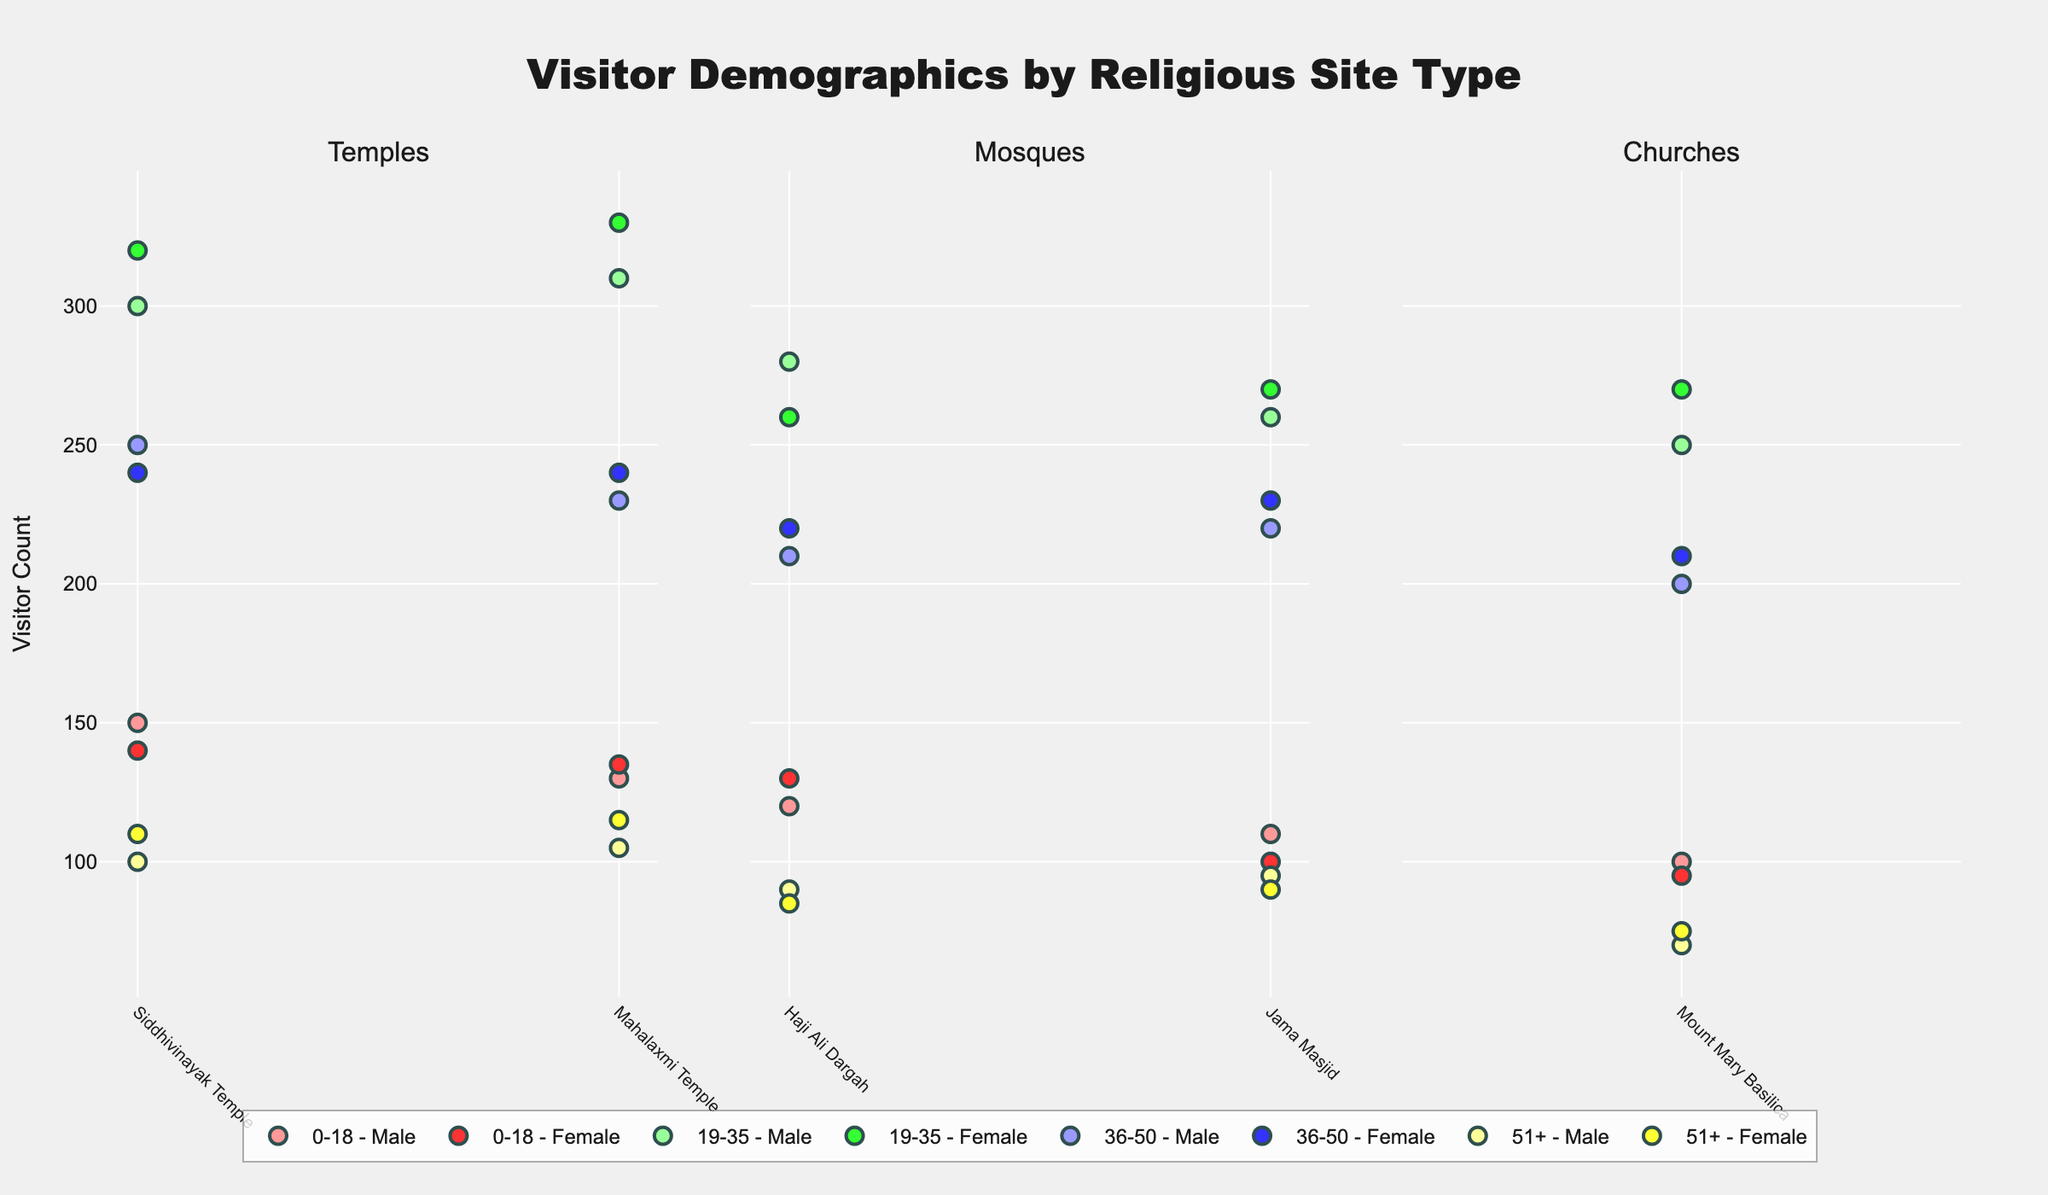What is the title of the figure? The title is usually displayed at the top of the figure in a larger font size. When referencing the title, you can simply read it off the figure.
Answer: Visitor Demographics by Religious Site Type Which religious site type has the highest number of visitors in the 19-35 age group for males? To find this, you will compare the height of the markers representing '19-35 - Male' visitors across the subplots for Temples, Mosques, and Churches. The tallest marker will indicate the highest number.
Answer: Mahalaxmi Temple What is the total number of female visitors aged 36-50 at all the religious sites? To find this, you need to sum up all the '36-50 - Female' visitor counts across all displayed sites. Specifically, find the sums for Siddhivinayak Temple, Haji Ali Dargah, Mount Mary Basilica, and other listed sites. For instance, (240 + 220 + 210 + 240 + 230).
Answer: 1140 How do the number of visitors aged 0-18 compare between Haji Ali Dargah and Mount Mary Basilica? Compare the y-values of the markers for '0-18 - Male' and '0-18 - Female' between these two sites. Specifically, calculate the difference in the number of visitors (e.g., (120+130) for Haji Ali Dargah and (100+95) for Mount Mary Basilica).
Answer: Haji Ali Dargah has more visitors Which gender generally visits the temples more often in the 19-35 age group? Examine the heights of markers representing male and female visitors aged 19-35 at the Temples. Compare them and see which gender has higher markers overall.
Answer: Female How many data points are represented for Mosques specifically? For each religious site type, count the number of distinct markers (data points) representing different age and gender groups. For Mosques, sum the markers representing different groups at respective Mosques. There are distinct age and gender groups: (8 markers per site) x (2 Mosques).
Answer: 16 Compare the average visitor counts for males aged 51+ between Temples and Mosques. Calculate the averages by summing counts for males aged 51+ and dividing by the number of sites. For example, in Temples ((100 + 105)/2) and in Mosques, (90 + 95)/2. Then, compare these averages.
Answer: Temples have a slightly higher average Which religious site has the least number of visitors aged 51+ in females? Observe the heights of markers representing '51+ - Female' visitors across all sites and identify the site with the lowest marker.
Answer: Haji Ali Dargah What's the total visitor count for Siddhivinayak Temple across all age groups and genders? Add up all the visitor counts for Siddhivinayak Temple as listed. So it’s (150 + 140 + 300 + 320 + 250 + 240 + 100 + 110).
Answer: 1610 